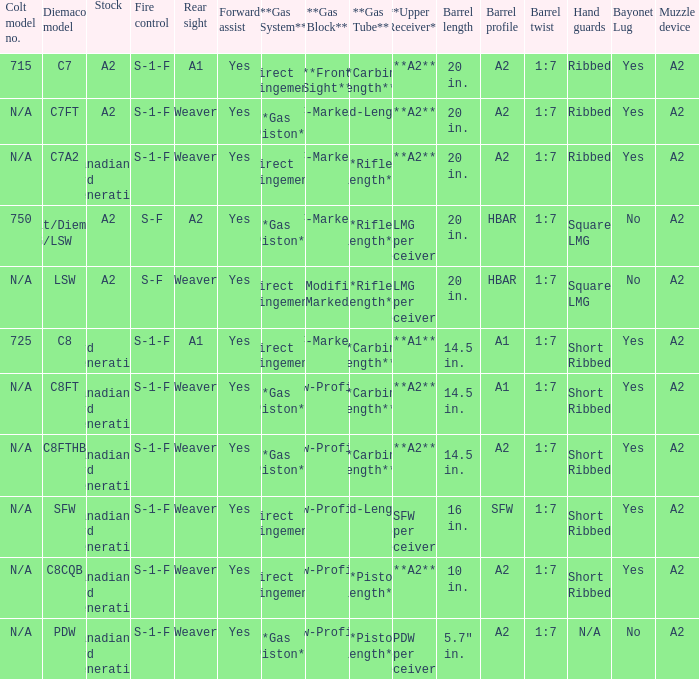Which Barrel twist has a Stock of canadian 3rd generation and a Hand guards of short ribbed? 1:7, 1:7, 1:7, 1:7. 